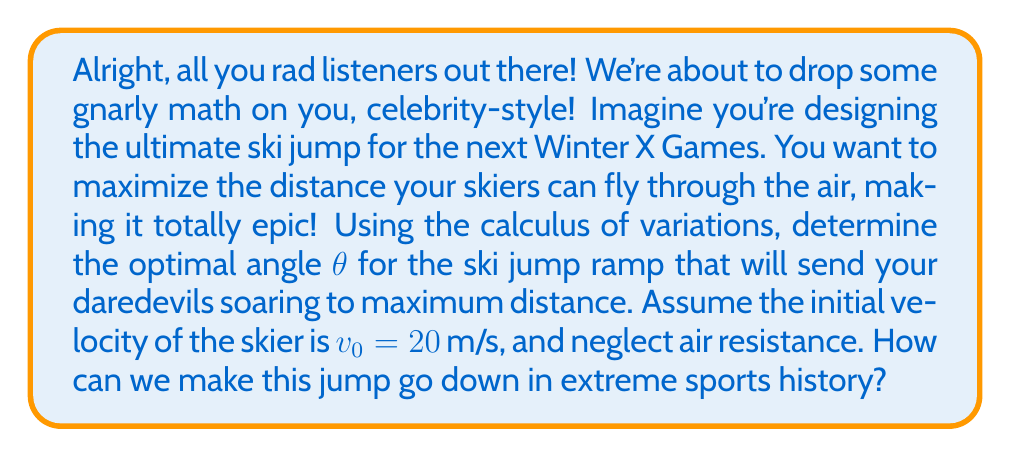Show me your answer to this math problem. Let's break this down step by step, keeping it cool and mathematical:

1) First, we need to set up our equations. The motion of the skier can be described using projectile motion equations:

   $$x(t) = v_0 \cos(\theta) t$$
   $$y(t) = v_0 \sin(\theta) t - \frac{1}{2}gt^2$$

   where $g$ is the acceleration due to gravity (9.8 m/s²).

2) The total distance traveled horizontally is what we want to maximize. This occurs when $y(t) = 0$ (when the skier lands). So, we need to solve:

   $$0 = v_0 \sin(\theta) t - \frac{1}{2}gt^2$$

3) Solving for $t$:

   $$t = \frac{2v_0 \sin(\theta)}{g}$$

4) Now, we can substitute this back into our equation for $x(t)$ to get the total distance:

   $$x = v_0 \cos(\theta) \cdot \frac{2v_0 \sin(\theta)}{g} = \frac{2v_0^2 \sin(\theta)\cos(\theta)}{g}$$

5) Using the trigonometric identity $\sin(2\theta) = 2\sin(\theta)\cos(\theta)$, we can simplify:

   $$x = \frac{v_0^2 \sin(2\theta)}{g}$$

6) To find the maximum, we need to differentiate with respect to $\theta$ and set it to zero:

   $$\frac{dx}{d\theta} = \frac{v_0^2 \cos(2\theta)}{g} = 0$$

7) This is true when $\cos(2\theta) = 0$, which occurs when $2\theta = 90°$ or $\theta = 45°$.

8) To confirm this is a maximum (not a minimum), we can check the second derivative is negative at this point (which it is).

Therefore, the optimal angle for maximum distance is 45°. This result is independent of the initial velocity, making it a universal result for projectile motion without air resistance.
Answer: The optimal angle for the ski jump ramp to maximize distance is $\theta = 45°$. 